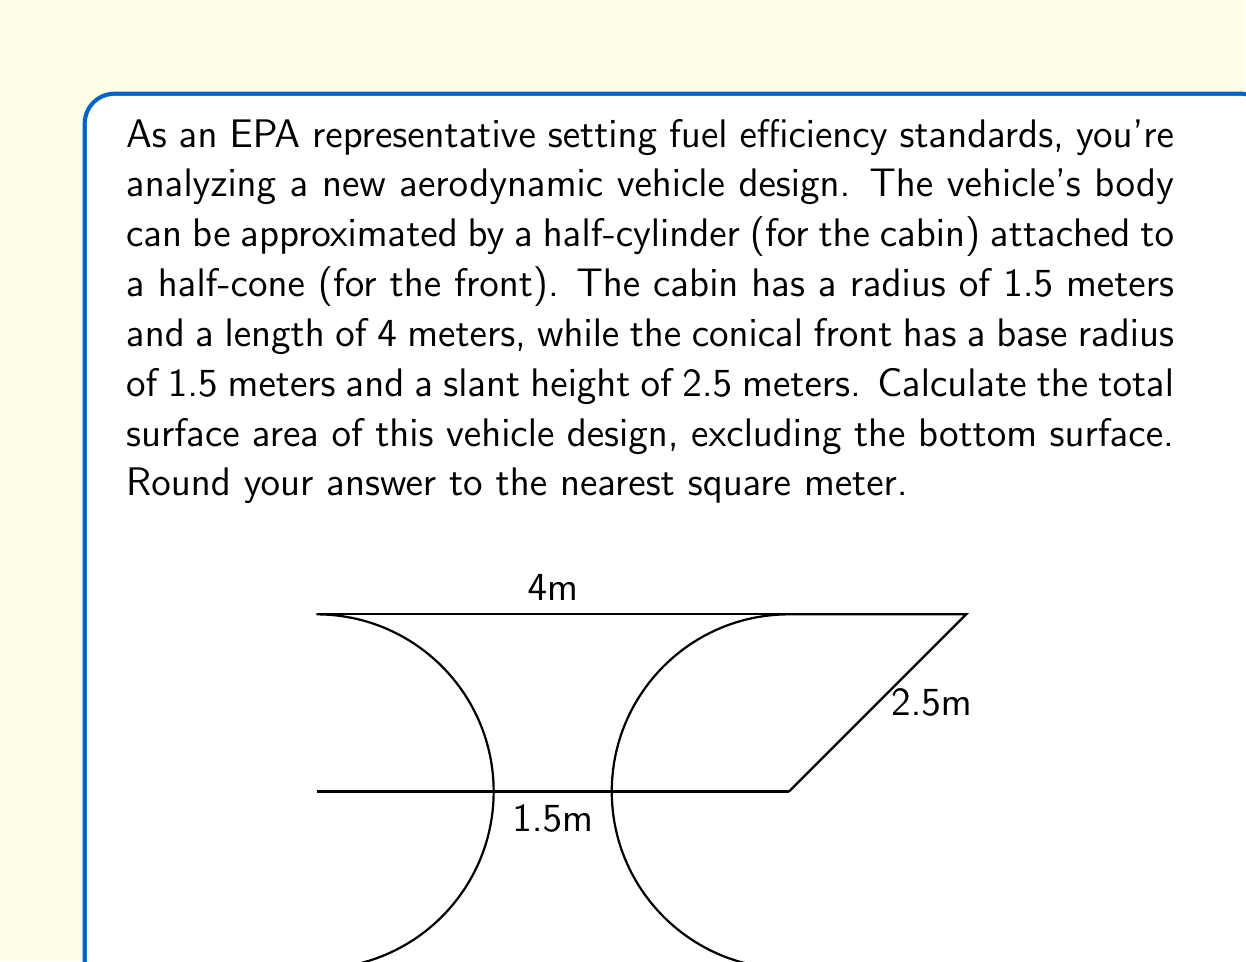Give your solution to this math problem. To solve this problem, we need to calculate the surface area of the half-cylinder and the lateral surface area of the half-cone, then add them together.

1. Surface area of the half-cylinder:
   - The curved surface area of a full cylinder is given by $2\pi r h$, where $r$ is the radius and $h$ is the height.
   - For a half-cylinder, we use half of this: $\pi r h$
   - We also need to add the area of one circular end: $\pi r^2$
   - Half-cylinder surface area = $\pi r h + \pi r^2 = \pi r(h + r)$
   - Substituting values: $SA_{cylinder} = \pi(1.5)(4 + 1.5) = 8.25\pi$ m²

2. Lateral surface area of the half-cone:
   - The lateral surface area of a full cone is given by $\pi rs$, where $r$ is the base radius and $s$ is the slant height.
   - For a half-cone, we use half of this: $\frac{1}{2}\pi rs$
   - Substituting values: $SA_{cone} = \frac{1}{2}\pi(1.5)(2.5) = 1.875\pi$ m²

3. Total surface area:
   $SA_{total} = SA_{cylinder} + SA_{cone} = 8.25\pi + 1.875\pi = 10.125\pi$ m²

4. Converting to numeric value and rounding:
   $SA_{total} = 10.125\pi \approx 31.81$ m²
   Rounded to the nearest square meter: 32 m²
Answer: The total surface area of the vehicle design is approximately 32 m². 